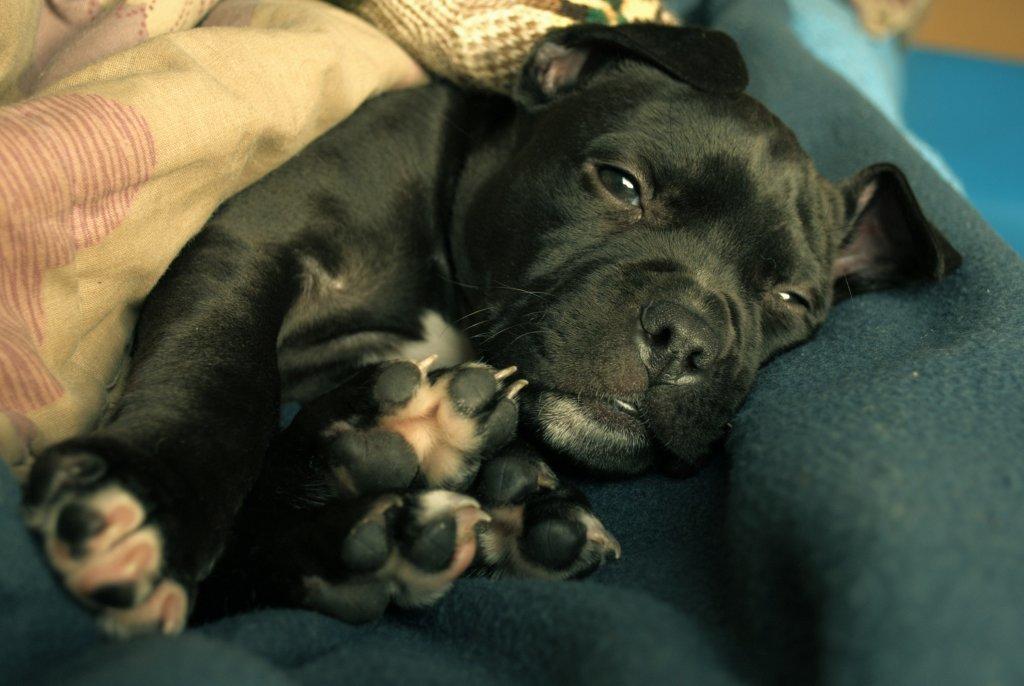Describe this image in one or two sentences. In this picture we can see a dog laying on the cloth. 